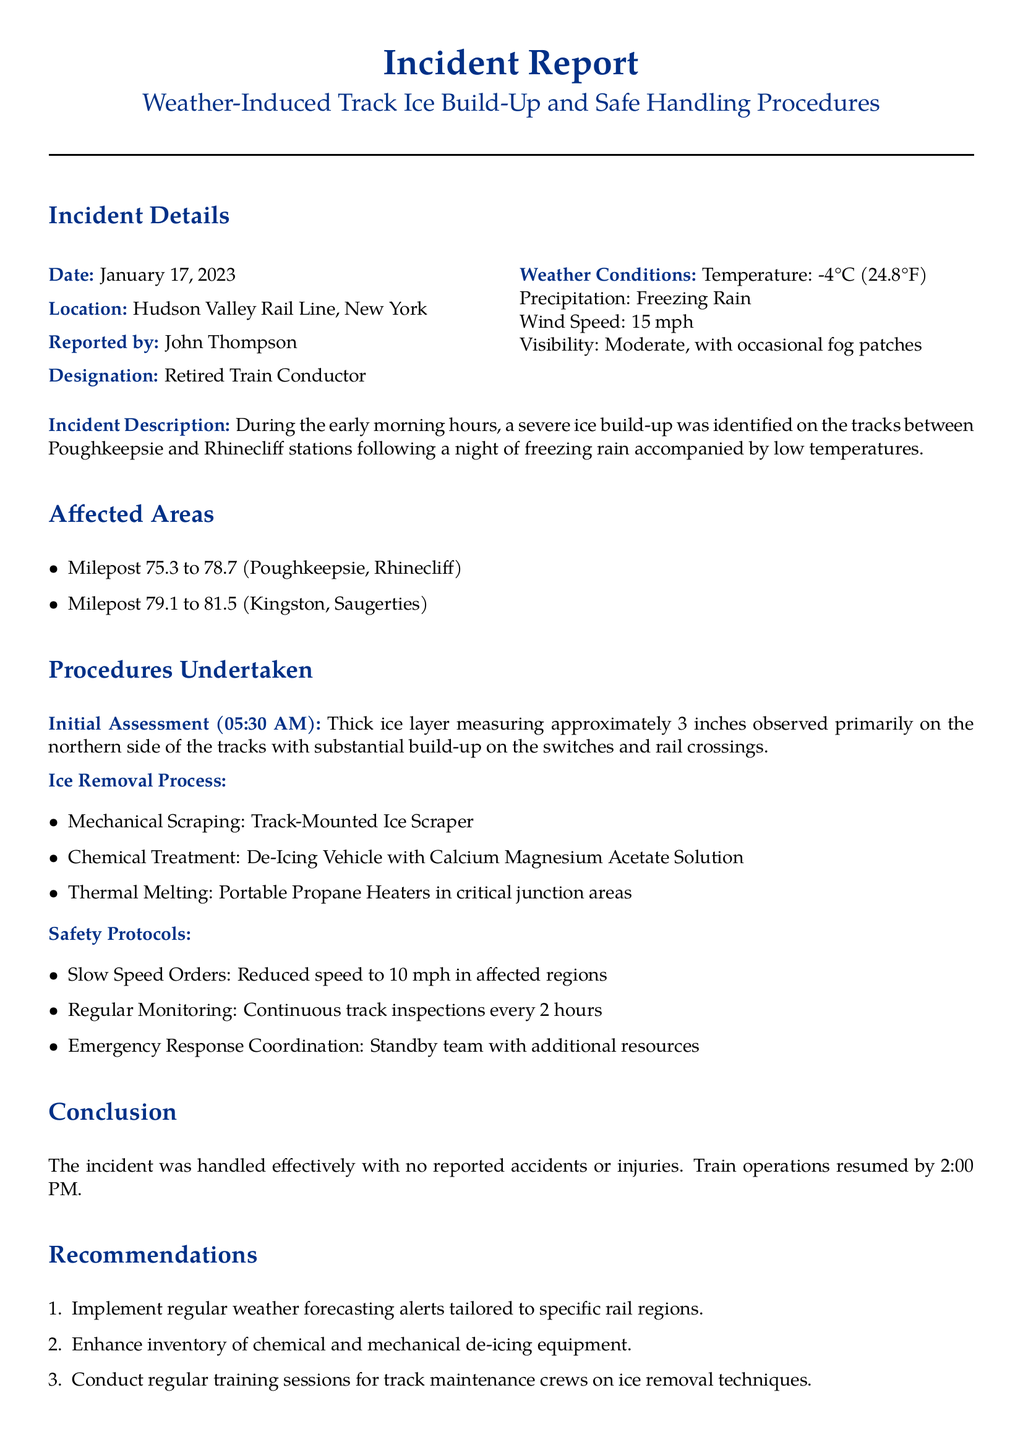What is the date of the incident? The date of the incident is mentioned in the document as January 17, 2023.
Answer: January 17, 2023 Who reported the incident? The document specifies that the incident was reported by John Thompson.
Answer: John Thompson What was the temperature at the time of the incident? The reported temperature is stated in the document as -4°C.
Answer: -4°C What was the maximum ice thickness observed? The document notes the thick ice layer measured approximately 3 inches.
Answer: 3 inches What procedures were used for ice removal? The document lists mechanical scraping, chemical treatment, and thermal melting as the procedures for ice removal.
Answer: Mechanical Scraping, Chemical Treatment, Thermal Melting What is the reduced speed limit in affected areas? According to the document, the speed was reduced to 10 mph in the affected regions.
Answer: 10 mph What time did train operations resume? The document indicates that train operations resumed by 2:00 PM.
Answer: 2:00 PM What recommendation was made regarding training sessions? The document recommends conducting regular training sessions for track maintenance crews on ice removal techniques.
Answer: Conduct regular training sessions What is the location of the incident? The incident occurred on the Hudson Valley Rail Line, New York.
Answer: Hudson Valley Rail Line, New York 